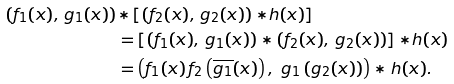Convert formula to latex. <formula><loc_0><loc_0><loc_500><loc_500>\left ( f _ { 1 } ( x ) , \, g _ { 1 } ( x ) \right ) & { \ast } \left [ \left ( f _ { 2 } ( x ) , \, g _ { 2 } ( x ) \right ) { \ast } h ( x ) \right ] \\ & = \left [ \left ( f _ { 1 } ( x ) , \, g _ { 1 } ( x ) \right ) { \ast } \left ( f _ { 2 } ( x ) , \, g _ { 2 } ( x ) \right ) \right ] { \ast } h ( x ) \\ & = \left ( f _ { 1 } ( x ) \, f _ { 2 } \left ( \overline { g _ { 1 } } ( x ) \right ) , \ g _ { 1 } \left ( g _ { 2 } ( x ) \right ) \right ) \ast h ( x ) .</formula> 